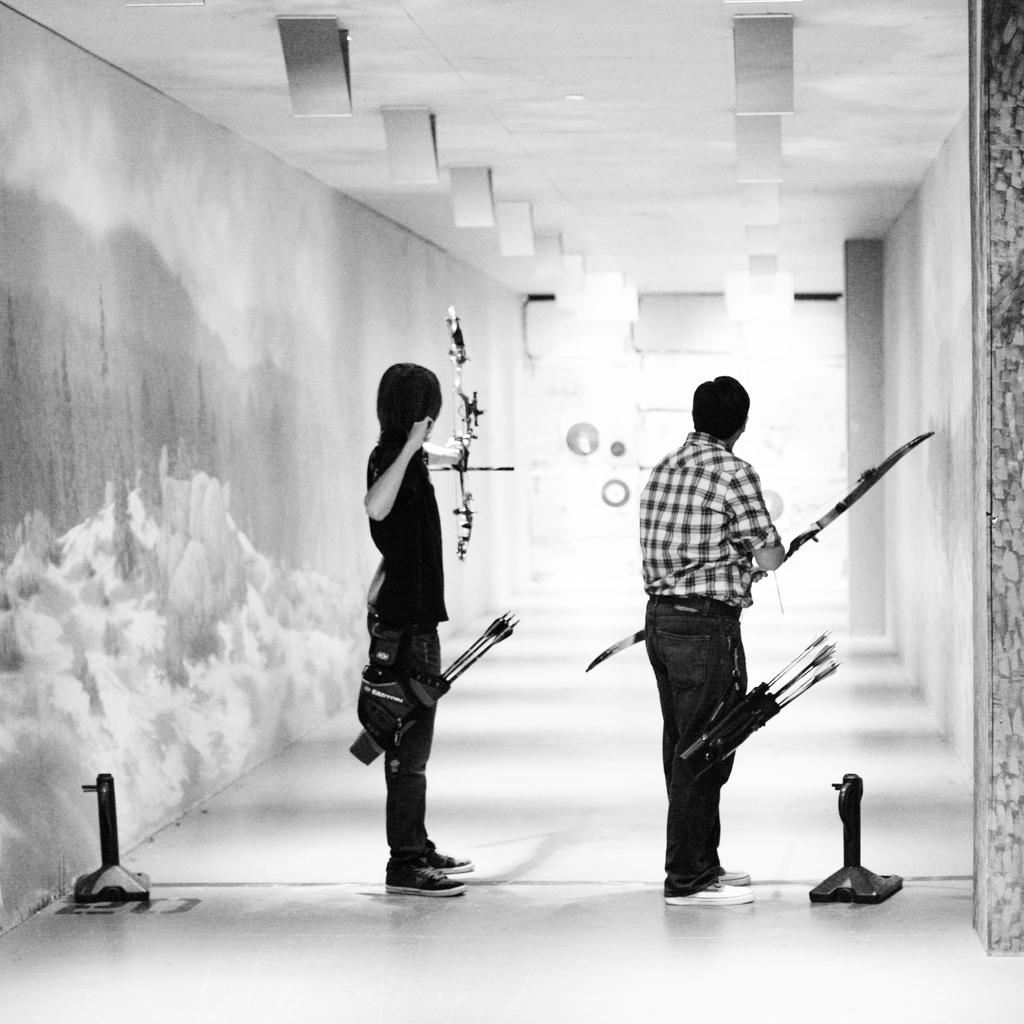How many people are in the image? There are two men in the image. Where are the men located in the image? The men are standing in a corridor. What are the men holding in the image? The men are holding bows and arrows. What are the men doing with the bows and arrows? The men are aiming at a target. What type of meat is being prepared in the image? There is no meat preparation visible in the image; the men are holding bows and arrows and aiming at a target. 